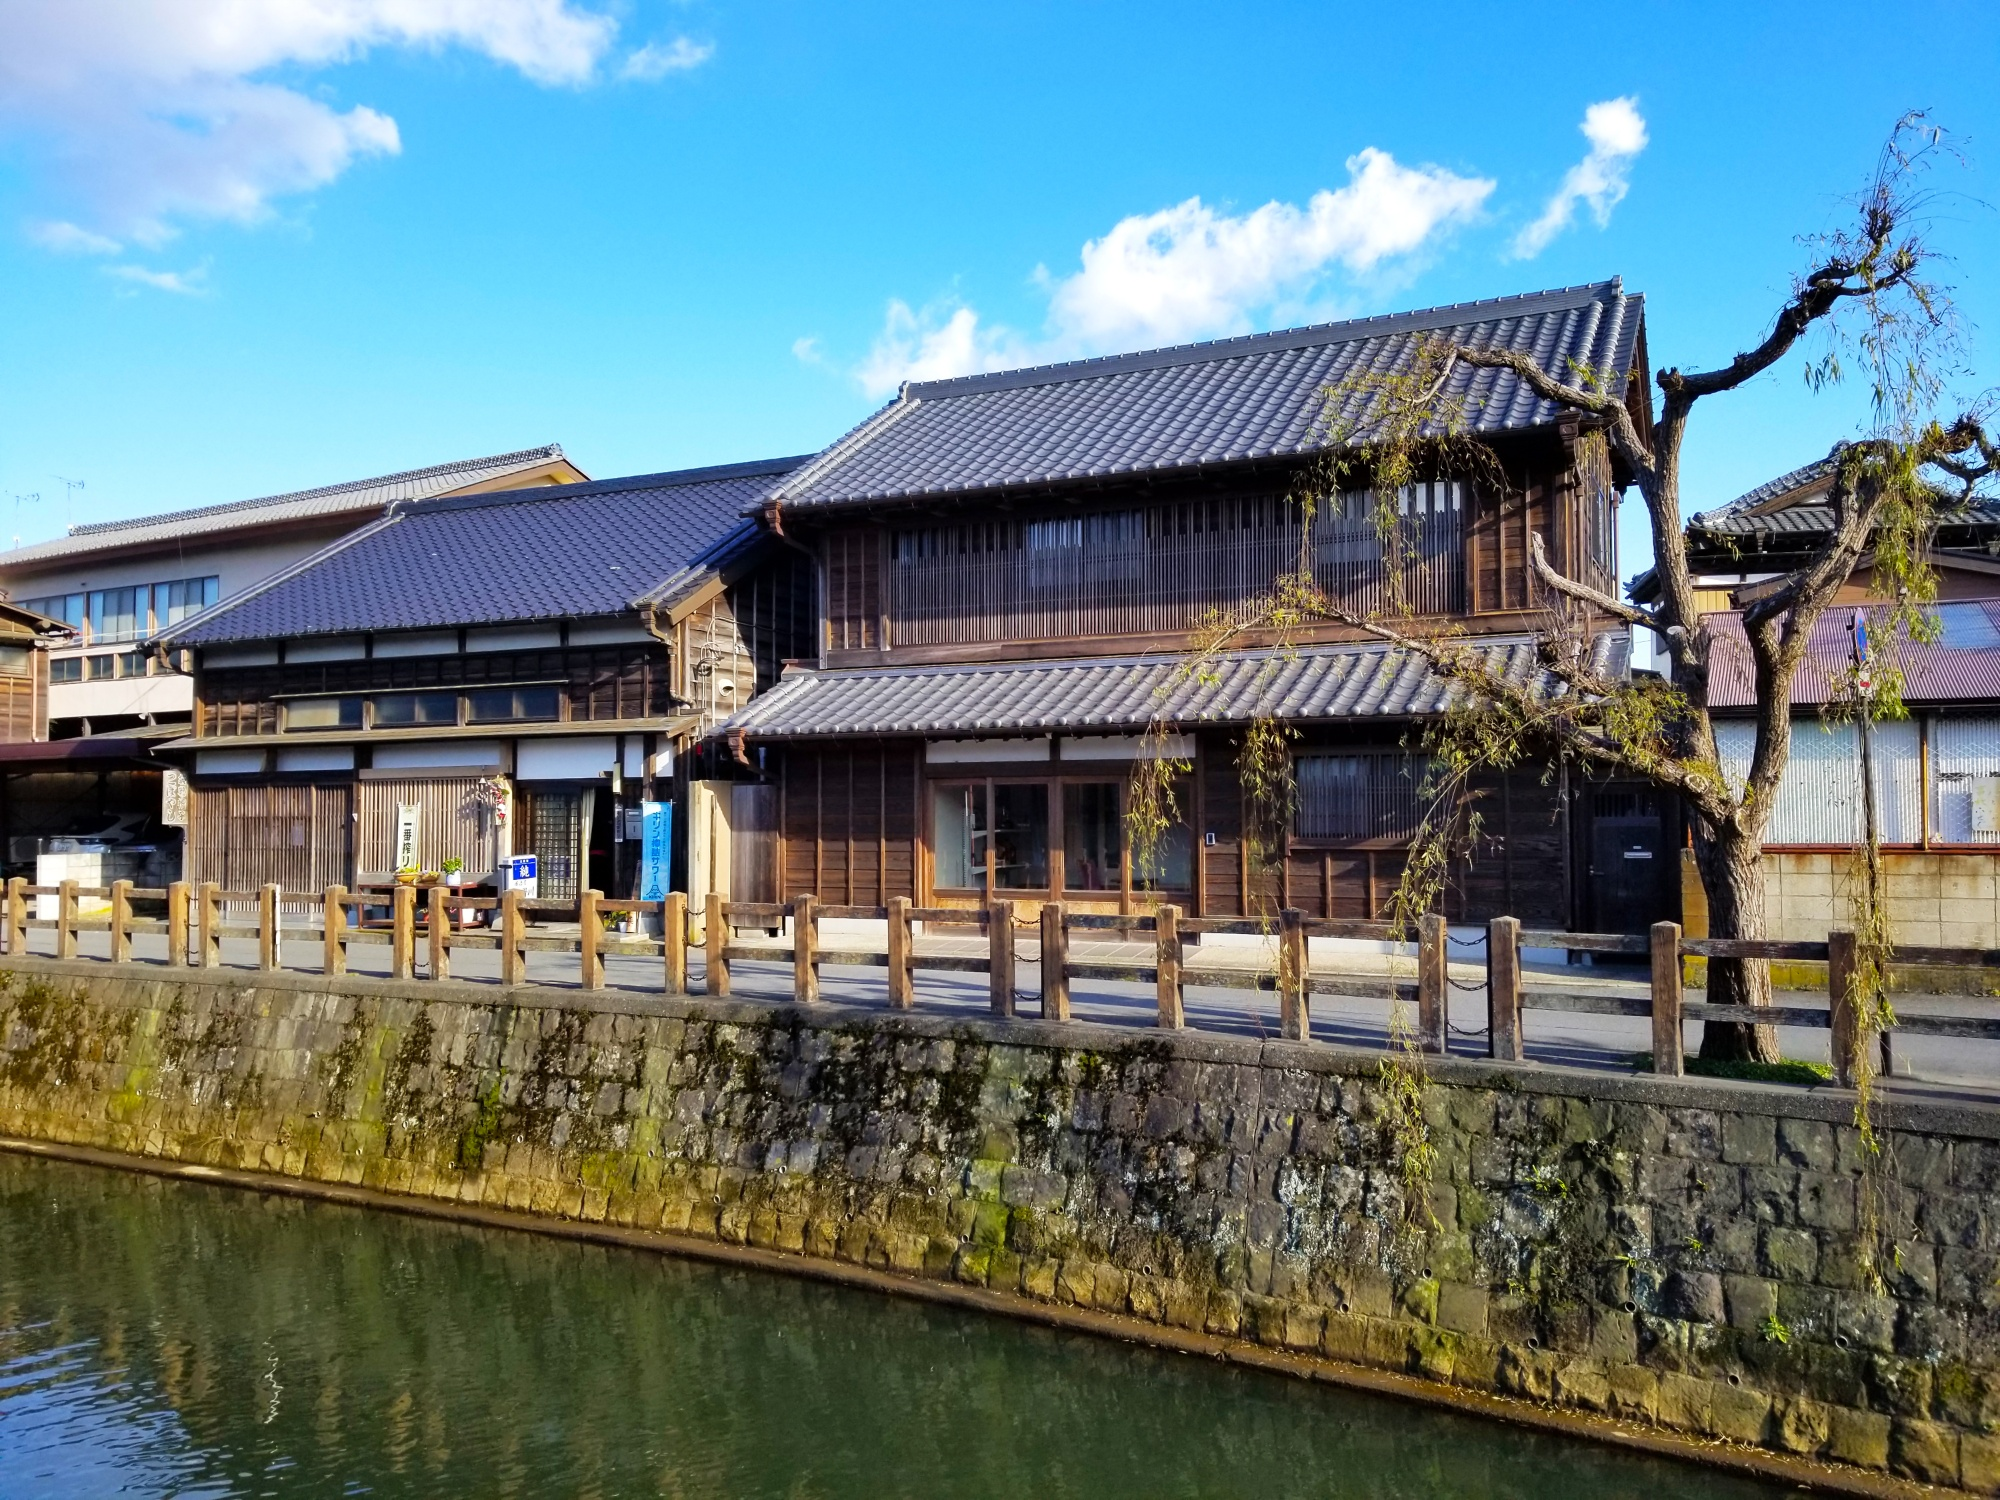What does this image tell us about the season and weather in Japan? The image reflects winter in Japan, captured through the bare branches of the prominent tree, which has lost its leaves in response to the cold temperatures. The sky, although bright, has patches of clouds, suggesting a typical chilly but clear winter day. Japanese winters vary across the country but what we see in this image matches typical winter climates in many regions where temperatures are cool but not extreme, and the landscape remains vivid and engaging despite the season. 